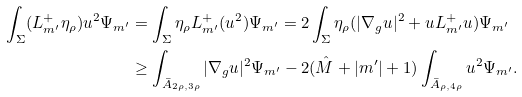<formula> <loc_0><loc_0><loc_500><loc_500>\int _ { \Sigma } ( \L L ^ { + } _ { m ^ { \prime } } \eta _ { \rho } ) u ^ { 2 } \Psi _ { m ^ { \prime } } & = \int _ { \Sigma } \eta _ { \rho } \L L ^ { + } _ { m ^ { \prime } } ( u ^ { 2 } ) \Psi _ { m ^ { \prime } } = 2 \int _ { \Sigma } \eta _ { \rho } ( | \nabla _ { g } u | ^ { 2 } + u \L L ^ { + } _ { m ^ { \prime } } u ) \Psi _ { m ^ { \prime } } \\ & \geq \int _ { \bar { A } _ { 2 \rho , 3 \rho } } | \nabla _ { g } u | ^ { 2 } \Psi _ { m ^ { \prime } } - 2 ( \hat { M } + | m ^ { \prime } | + 1 ) \int _ { \bar { A } _ { \rho , 4 \rho } } u ^ { 2 } \Psi _ { m ^ { \prime } } .</formula> 